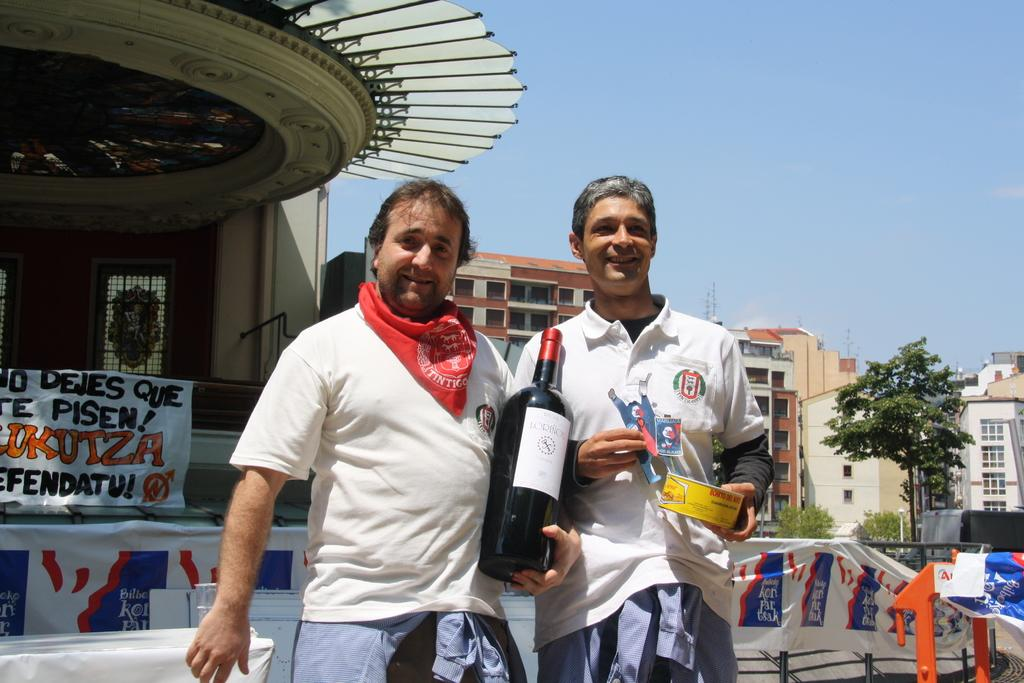What type of structures can be seen in the image? There are buildings in the image. What other elements can be seen in the image besides the buildings? There are trees in the image. How many people are present in the image? There are two persons standing in the image. What objects are the men holding in the image? One man is holding a wine bottle, and another man is holding a box. What type of battle is taking place in the image? There is no battle present in the image; it features buildings, trees, and two men holding a wine bottle and a box. What liquid is being pushed by the men in the image? There is no liquid being pushed by the men in the image; they are holding a wine bottle and a box. 